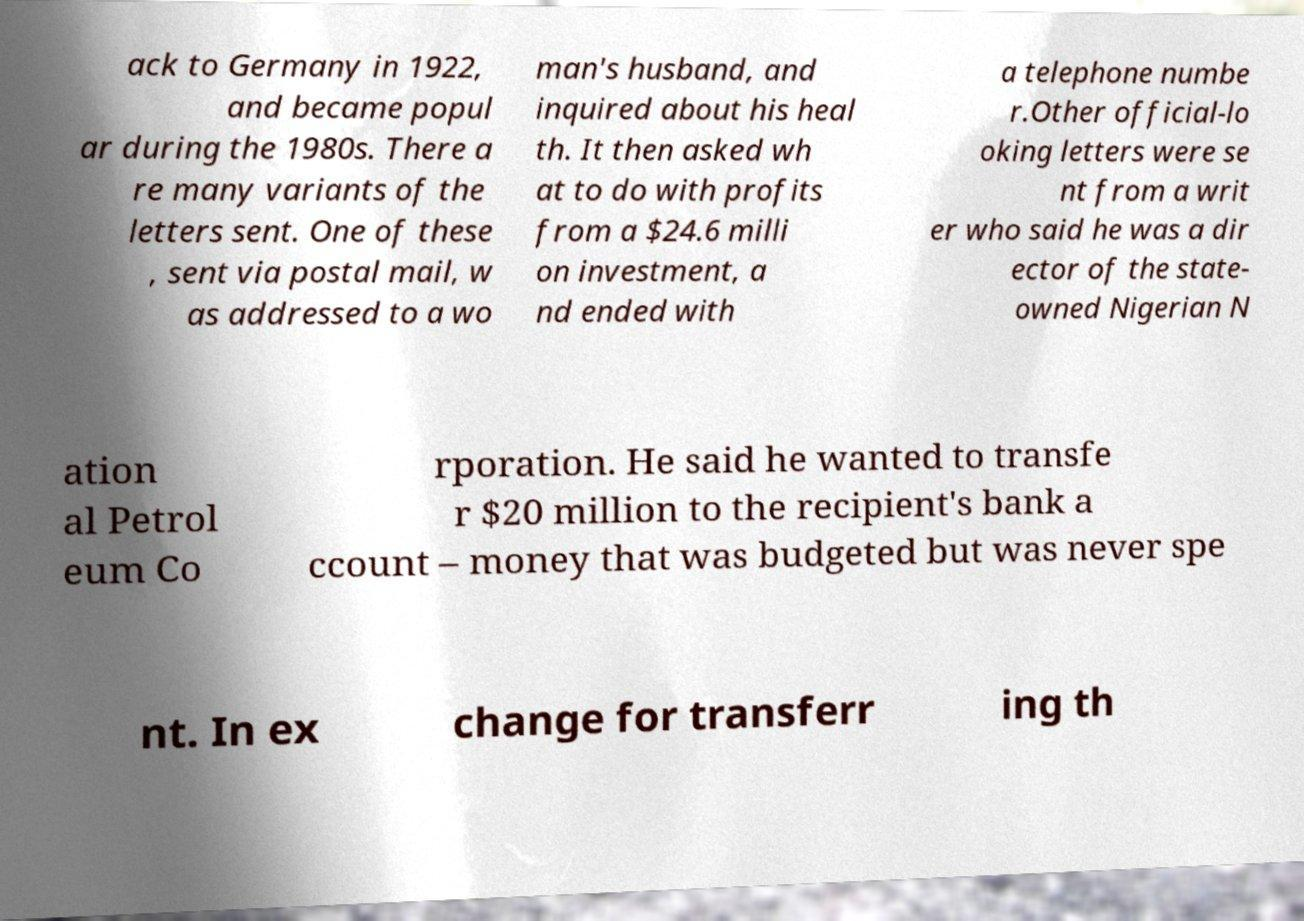Can you accurately transcribe the text from the provided image for me? ack to Germany in 1922, and became popul ar during the 1980s. There a re many variants of the letters sent. One of these , sent via postal mail, w as addressed to a wo man's husband, and inquired about his heal th. It then asked wh at to do with profits from a $24.6 milli on investment, a nd ended with a telephone numbe r.Other official-lo oking letters were se nt from a writ er who said he was a dir ector of the state- owned Nigerian N ation al Petrol eum Co rporation. He said he wanted to transfe r $20 million to the recipient's bank a ccount – money that was budgeted but was never spe nt. In ex change for transferr ing th 